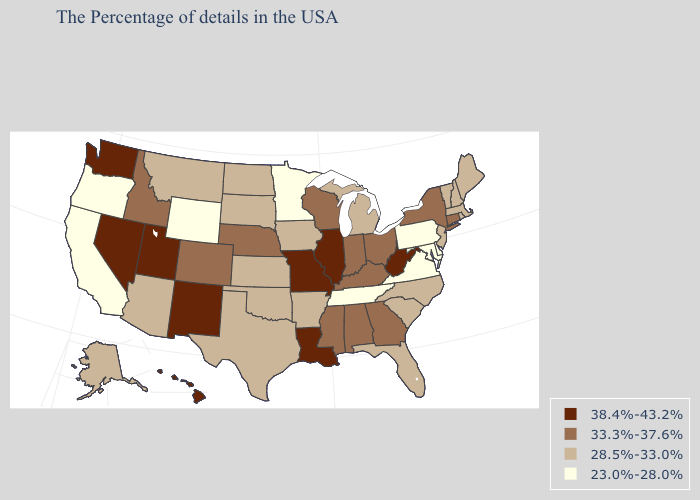Does Missouri have the lowest value in the MidWest?
Quick response, please. No. Does Missouri have the same value as Utah?
Give a very brief answer. Yes. Name the states that have a value in the range 28.5%-33.0%?
Answer briefly. Maine, Massachusetts, Rhode Island, New Hampshire, Vermont, New Jersey, North Carolina, South Carolina, Florida, Michigan, Arkansas, Iowa, Kansas, Oklahoma, Texas, South Dakota, North Dakota, Montana, Arizona, Alaska. Which states hav the highest value in the Northeast?
Be succinct. Connecticut, New York. What is the highest value in states that border Connecticut?
Answer briefly. 33.3%-37.6%. Name the states that have a value in the range 38.4%-43.2%?
Concise answer only. West Virginia, Illinois, Louisiana, Missouri, New Mexico, Utah, Nevada, Washington, Hawaii. Which states hav the highest value in the MidWest?
Answer briefly. Illinois, Missouri. What is the value of North Carolina?
Quick response, please. 28.5%-33.0%. What is the value of Massachusetts?
Write a very short answer. 28.5%-33.0%. Among the states that border Arizona , does New Mexico have the highest value?
Concise answer only. Yes. Name the states that have a value in the range 33.3%-37.6%?
Quick response, please. Connecticut, New York, Ohio, Georgia, Kentucky, Indiana, Alabama, Wisconsin, Mississippi, Nebraska, Colorado, Idaho. Among the states that border Oklahoma , does New Mexico have the lowest value?
Keep it brief. No. Which states have the highest value in the USA?
Write a very short answer. West Virginia, Illinois, Louisiana, Missouri, New Mexico, Utah, Nevada, Washington, Hawaii. Name the states that have a value in the range 33.3%-37.6%?
Give a very brief answer. Connecticut, New York, Ohio, Georgia, Kentucky, Indiana, Alabama, Wisconsin, Mississippi, Nebraska, Colorado, Idaho. Does Wisconsin have the same value as Connecticut?
Quick response, please. Yes. 